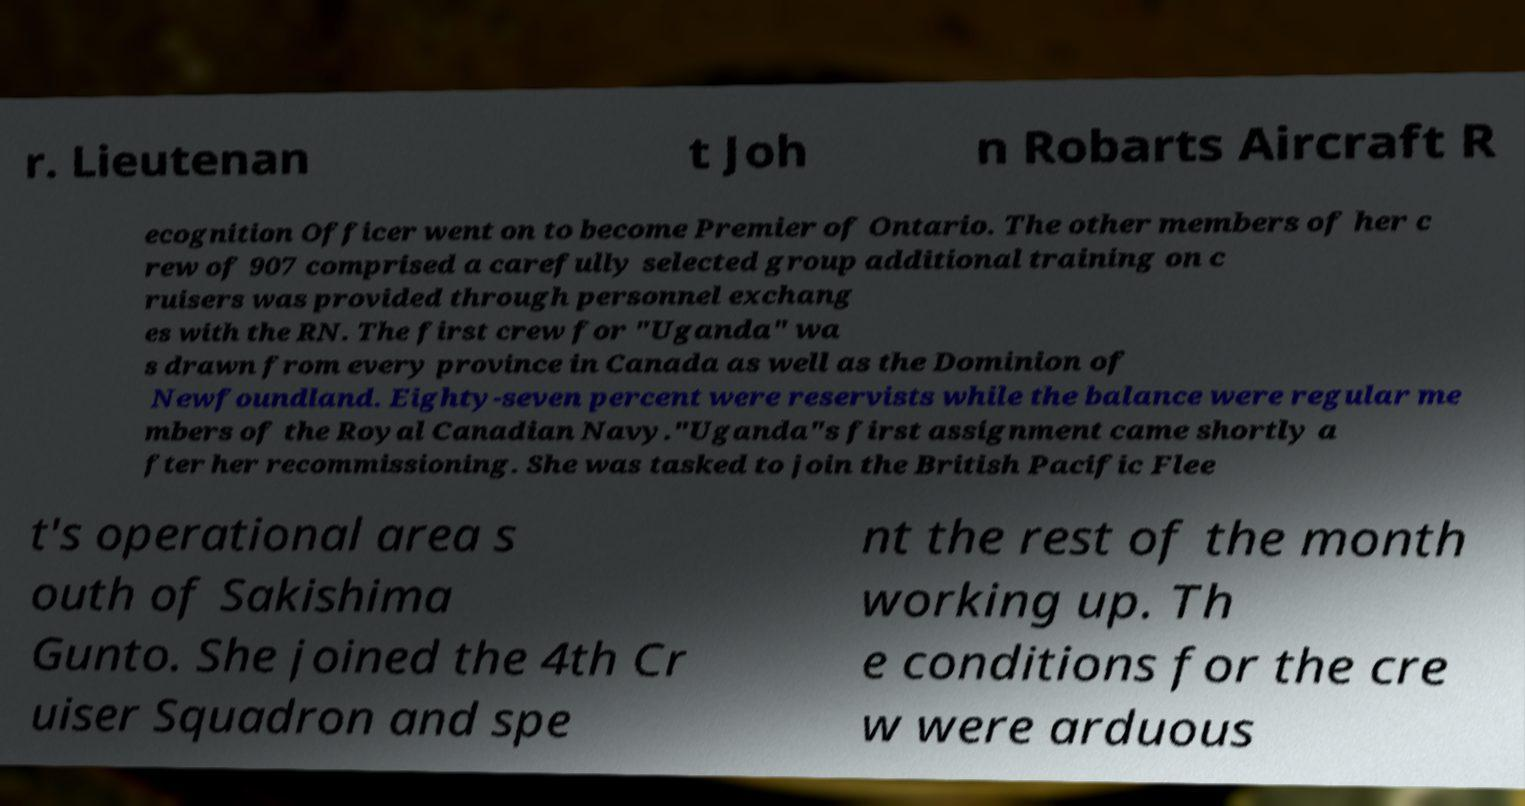Can you read and provide the text displayed in the image?This photo seems to have some interesting text. Can you extract and type it out for me? r. Lieutenan t Joh n Robarts Aircraft R ecognition Officer went on to become Premier of Ontario. The other members of her c rew of 907 comprised a carefully selected group additional training on c ruisers was provided through personnel exchang es with the RN. The first crew for "Uganda" wa s drawn from every province in Canada as well as the Dominion of Newfoundland. Eighty-seven percent were reservists while the balance were regular me mbers of the Royal Canadian Navy."Uganda"s first assignment came shortly a fter her recommissioning. She was tasked to join the British Pacific Flee t's operational area s outh of Sakishima Gunto. She joined the 4th Cr uiser Squadron and spe nt the rest of the month working up. Th e conditions for the cre w were arduous 